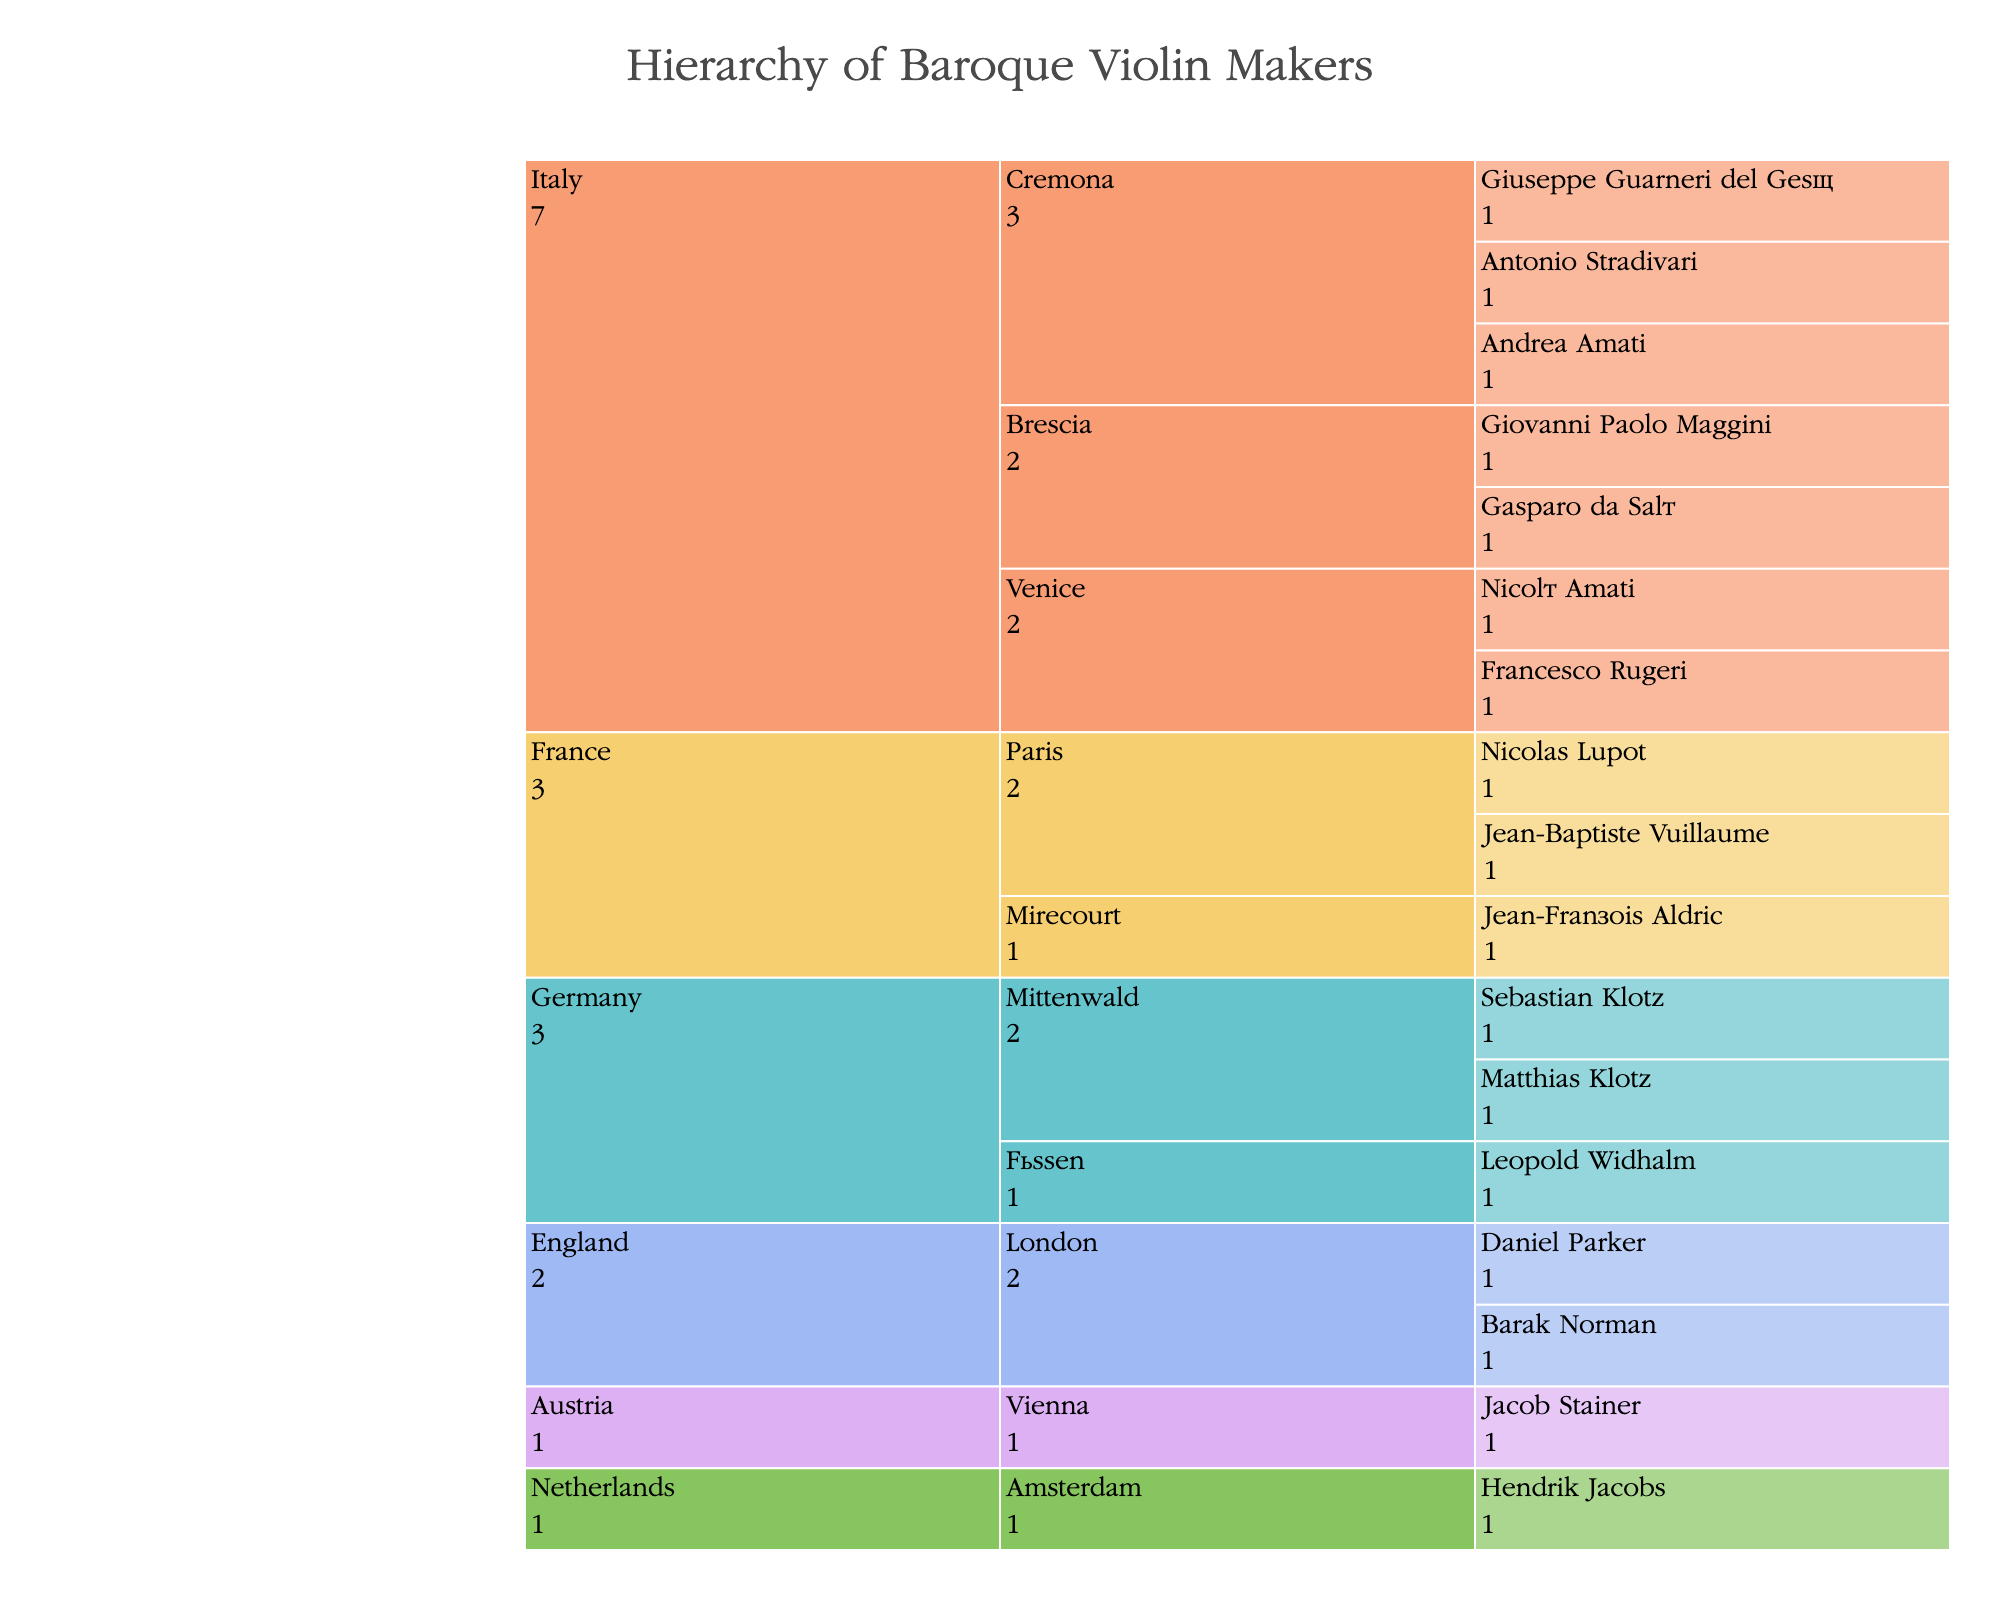How many countries are represented in the hierarchy of Baroque violin makers? To determine the number of countries, count the different country categories present in the icicle chart. Based on the given data, there are Italy, Germany, France, Netherlands, England, and Austria.
Answer: 6 Which country has the most schools of violin making? Look at the hierarchy and count the schools under each country. Italy has Cremona, Venice, Brescia; Germany has Mittenwald, Füssen; France has Paris, Mirecourt. The other countries appear to have only one school each.
Answer: Italy How many makers are listed under the Cremona school in Italy? Identify the Cremona school under the Italy category and count the number of violin makers. According to the data, there are three: Antonio Stradivari, Giuseppe Guarneri del Gesù, and Andrea Amati.
Answer: 3 Which school does Nicolò Amati belong to? Find Nicolò Amati in the chart and trace back to identify his school. The data indicates that he belongs to the Venice school in Italy.
Answer: Venice How many violin makers are represented from Mittenwald, Germany? Locate the Mittenwald school under Germany and count the number of makers. The data indicates there are two: Matthias Klotz and Sebastian Klotz.
Answer: 2 Which country has more violin makers, France or England? Count the number of violin makers listed under France and England. France has Nicolas Lupot, Jean-Baptiste Vuillaume, and Jean-François Aldric (3 in total). England has Daniel Parker and Barak Norman (2 in total).
Answer: France What is the proportion of violin makers from Italy compared to the total number of makers in the chart? First, count the total number of violin makers listed (17). Then, count the number of Italian makers (7). The proportion would be 7/17.
Answer: 7/17 Is there any school of violin making outside of Italy with only one violin maker? Check each school outside Italy and see which has only one listed maker. The schools and their counts are: Paris (2), Mirecourt (1), Amsterdam (1), London (2), Vienna (1).
Answer: Mirecourt, Amsterdam, Vienna Which school has the fewest violin makers? Look at the counts for each school. Schools with only one maker are Venice, Brescia, Füssen, Mirecourt, Amsterdam, and Vienna. Given the data and the requirement to be precise in mentioning just one, we see that each has an equal count (1).
Answer: Multiple (Venice, Brescia, Füssen, Mirecourt, Amsterdam, Vienna) How are violin makers from the Netherlands categorized in the hierarchy? Trace the category path from the root to the maker starting from Netherlands; there is only one school, Amsterdam, under Netherlands and Hendrik Jacobs as the maker.
Answer: Netherlands > Amsterdam 